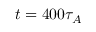<formula> <loc_0><loc_0><loc_500><loc_500>t = 4 0 0 \tau _ { A }</formula> 